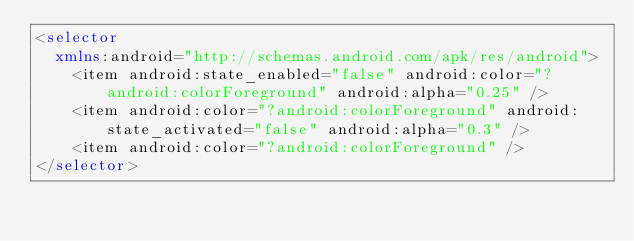<code> <loc_0><loc_0><loc_500><loc_500><_XML_><selector
  xmlns:android="http://schemas.android.com/apk/res/android">
    <item android:state_enabled="false" android:color="?android:colorForeground" android:alpha="0.25" />
    <item android:color="?android:colorForeground" android:state_activated="false" android:alpha="0.3" />
    <item android:color="?android:colorForeground" />
</selector></code> 